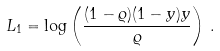Convert formula to latex. <formula><loc_0><loc_0><loc_500><loc_500>L _ { 1 } = \log \left ( \frac { ( 1 - \varrho ) ( 1 - y ) y } { \varrho } \right ) \, .</formula> 